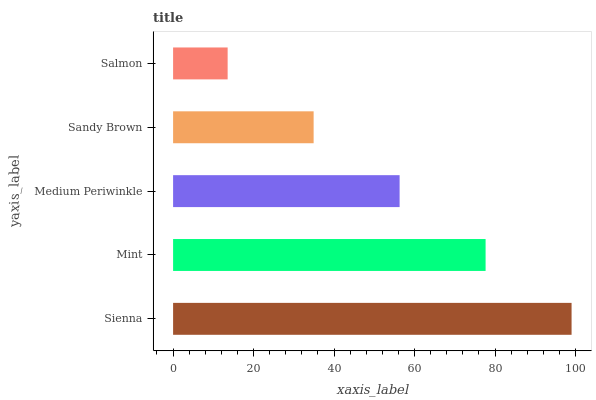Is Salmon the minimum?
Answer yes or no. Yes. Is Sienna the maximum?
Answer yes or no. Yes. Is Mint the minimum?
Answer yes or no. No. Is Mint the maximum?
Answer yes or no. No. Is Sienna greater than Mint?
Answer yes or no. Yes. Is Mint less than Sienna?
Answer yes or no. Yes. Is Mint greater than Sienna?
Answer yes or no. No. Is Sienna less than Mint?
Answer yes or no. No. Is Medium Periwinkle the high median?
Answer yes or no. Yes. Is Medium Periwinkle the low median?
Answer yes or no. Yes. Is Sienna the high median?
Answer yes or no. No. Is Sandy Brown the low median?
Answer yes or no. No. 